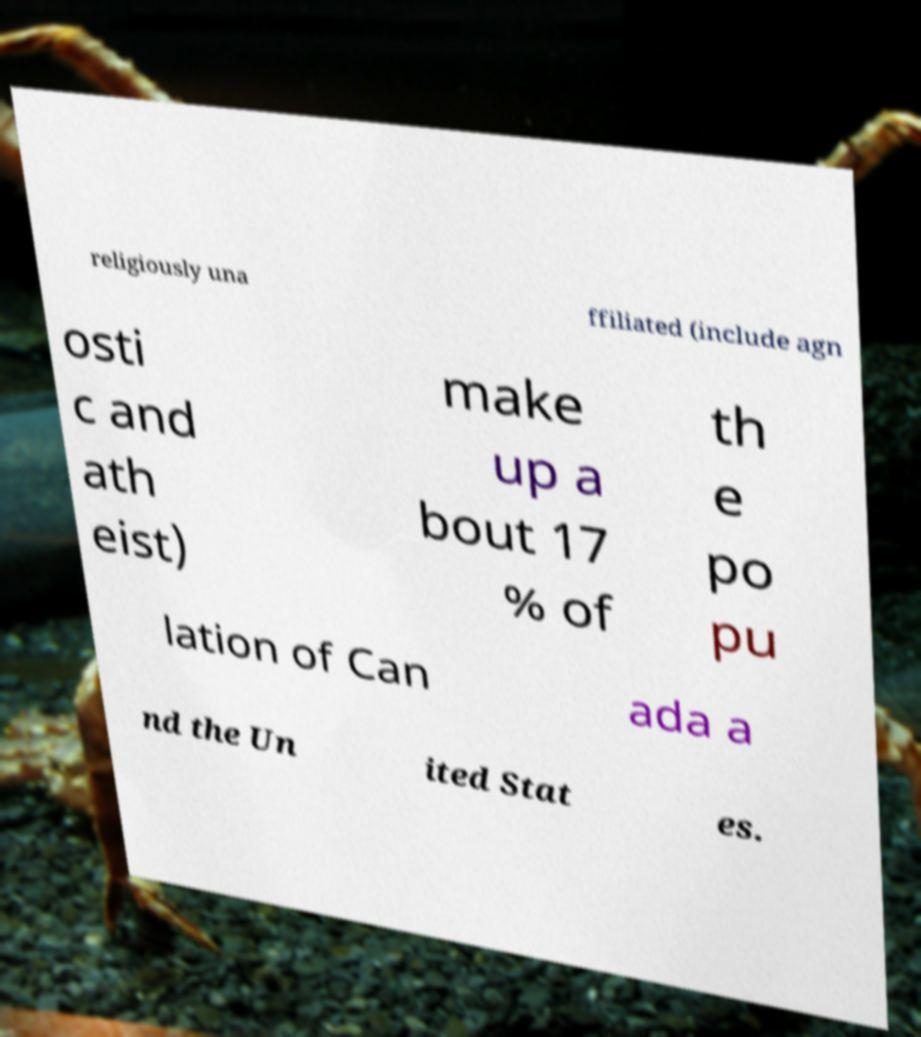What messages or text are displayed in this image? I need them in a readable, typed format. religiously una ffiliated (include agn osti c and ath eist) make up a bout 17 % of th e po pu lation of Can ada a nd the Un ited Stat es. 